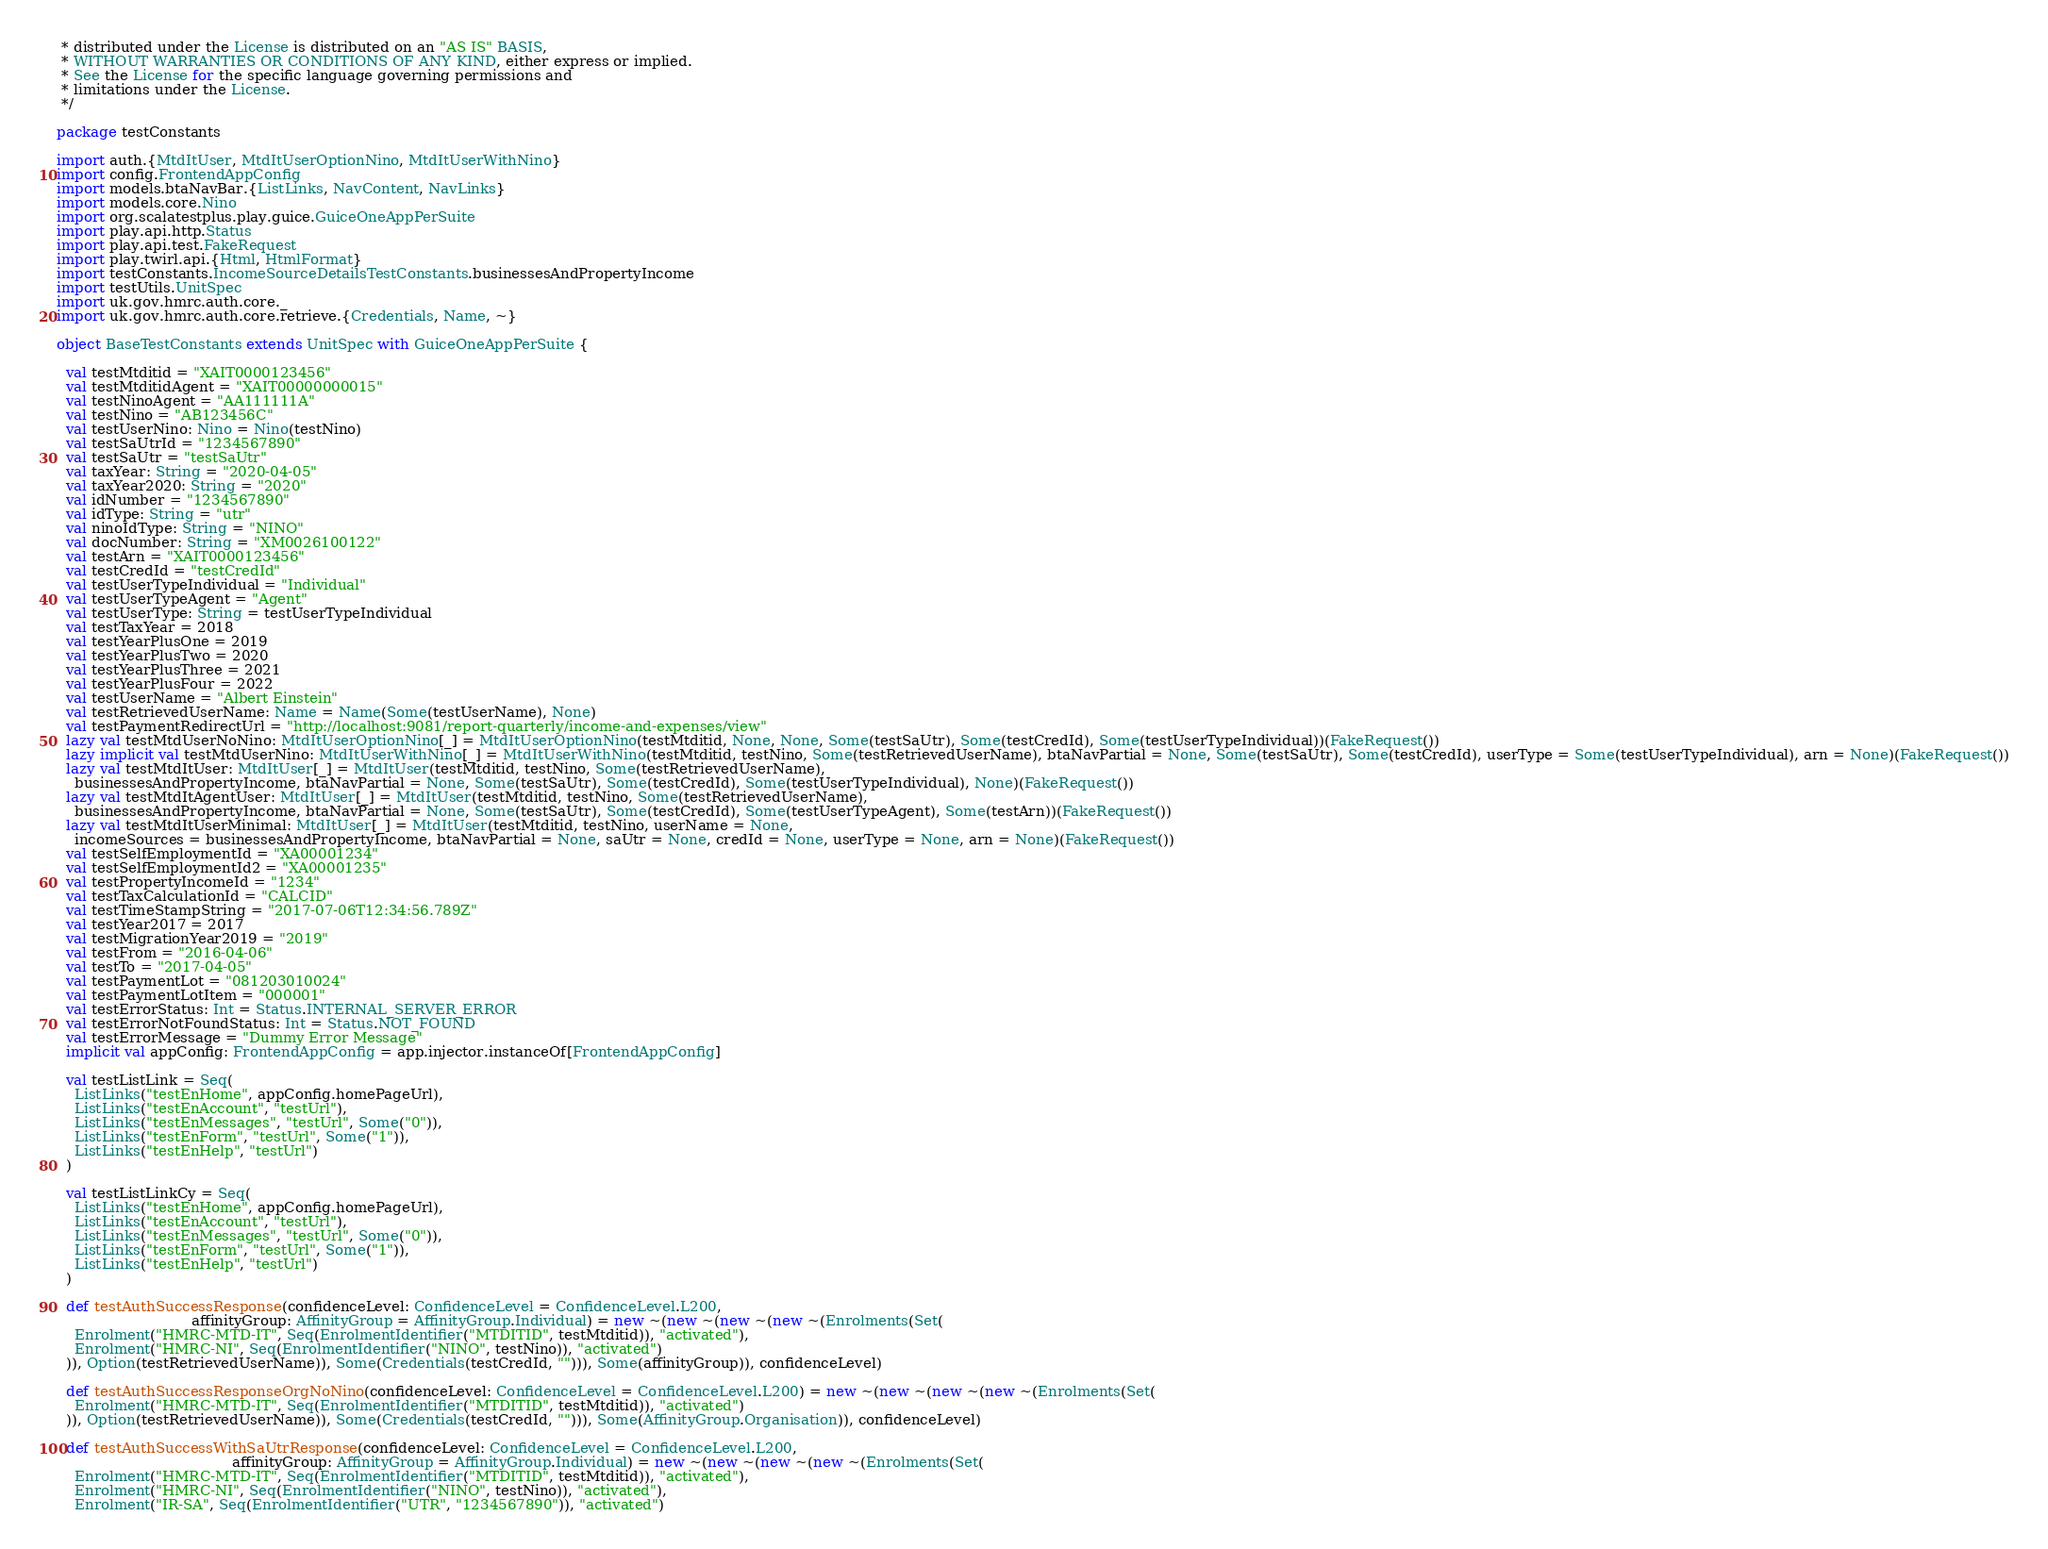Convert code to text. <code><loc_0><loc_0><loc_500><loc_500><_Scala_> * distributed under the License is distributed on an "AS IS" BASIS,
 * WITHOUT WARRANTIES OR CONDITIONS OF ANY KIND, either express or implied.
 * See the License for the specific language governing permissions and
 * limitations under the License.
 */

package testConstants

import auth.{MtdItUser, MtdItUserOptionNino, MtdItUserWithNino}
import config.FrontendAppConfig
import models.btaNavBar.{ListLinks, NavContent, NavLinks}
import models.core.Nino
import org.scalatestplus.play.guice.GuiceOneAppPerSuite
import play.api.http.Status
import play.api.test.FakeRequest
import play.twirl.api.{Html, HtmlFormat}
import testConstants.IncomeSourceDetailsTestConstants.businessesAndPropertyIncome
import testUtils.UnitSpec
import uk.gov.hmrc.auth.core._
import uk.gov.hmrc.auth.core.retrieve.{Credentials, Name, ~}

object BaseTestConstants extends UnitSpec with GuiceOneAppPerSuite {

  val testMtditid = "XAIT0000123456"
  val testMtditidAgent = "XAIT00000000015"
  val testNinoAgent = "AA111111A"
  val testNino = "AB123456C"
  val testUserNino: Nino = Nino(testNino)
  val testSaUtrId = "1234567890"
  val testSaUtr = "testSaUtr"
  val taxYear: String = "2020-04-05"
  val taxYear2020: String = "2020"
  val idNumber = "1234567890"
  val idType: String = "utr"
  val ninoIdType: String = "NINO"
  val docNumber: String = "XM0026100122"
  val testArn = "XAIT0000123456"
  val testCredId = "testCredId"
  val testUserTypeIndividual = "Individual"
  val testUserTypeAgent = "Agent"
  val testUserType: String = testUserTypeIndividual
  val testTaxYear = 2018
  val testYearPlusOne = 2019
  val testYearPlusTwo = 2020
  val testYearPlusThree = 2021
  val testYearPlusFour = 2022
  val testUserName = "Albert Einstein"
  val testRetrievedUserName: Name = Name(Some(testUserName), None)
  val testPaymentRedirectUrl = "http://localhost:9081/report-quarterly/income-and-expenses/view"
  lazy val testMtdUserNoNino: MtdItUserOptionNino[_] = MtdItUserOptionNino(testMtditid, None, None, Some(testSaUtr), Some(testCredId), Some(testUserTypeIndividual))(FakeRequest())
  lazy implicit val testMtdUserNino: MtdItUserWithNino[_] = MtdItUserWithNino(testMtditid, testNino, Some(testRetrievedUserName), btaNavPartial = None, Some(testSaUtr), Some(testCredId), userType = Some(testUserTypeIndividual), arn = None)(FakeRequest())
  lazy val testMtdItUser: MtdItUser[_] = MtdItUser(testMtditid, testNino, Some(testRetrievedUserName),
    businessesAndPropertyIncome, btaNavPartial = None, Some(testSaUtr), Some(testCredId), Some(testUserTypeIndividual), None)(FakeRequest())
  lazy val testMtdItAgentUser: MtdItUser[_] = MtdItUser(testMtditid, testNino, Some(testRetrievedUserName),
    businessesAndPropertyIncome, btaNavPartial = None, Some(testSaUtr), Some(testCredId), Some(testUserTypeAgent), Some(testArn))(FakeRequest())
  lazy val testMtdItUserMinimal: MtdItUser[_] = MtdItUser(testMtditid, testNino, userName = None,
    incomeSources = businessesAndPropertyIncome, btaNavPartial = None, saUtr = None, credId = None, userType = None, arn = None)(FakeRequest())
  val testSelfEmploymentId = "XA00001234"
  val testSelfEmploymentId2 = "XA00001235"
  val testPropertyIncomeId = "1234"
  val testTaxCalculationId = "CALCID"
  val testTimeStampString = "2017-07-06T12:34:56.789Z"
  val testYear2017 = 2017
  val testMigrationYear2019 = "2019"
  val testFrom = "2016-04-06"
  val testTo = "2017-04-05"
  val testPaymentLot = "081203010024"
  val testPaymentLotItem = "000001"
  val testErrorStatus: Int = Status.INTERNAL_SERVER_ERROR
  val testErrorNotFoundStatus: Int = Status.NOT_FOUND
  val testErrorMessage = "Dummy Error Message"
  implicit val appConfig: FrontendAppConfig = app.injector.instanceOf[FrontendAppConfig]

  val testListLink = Seq(
    ListLinks("testEnHome", appConfig.homePageUrl),
    ListLinks("testEnAccount", "testUrl"),
    ListLinks("testEnMessages", "testUrl", Some("0")),
    ListLinks("testEnForm", "testUrl", Some("1")),
    ListLinks("testEnHelp", "testUrl")
  )

  val testListLinkCy = Seq(
    ListLinks("testEnHome", appConfig.homePageUrl),
    ListLinks("testEnAccount", "testUrl"),
    ListLinks("testEnMessages", "testUrl", Some("0")),
    ListLinks("testEnForm", "testUrl", Some("1")),
    ListLinks("testEnHelp", "testUrl")
  )

  def testAuthSuccessResponse(confidenceLevel: ConfidenceLevel = ConfidenceLevel.L200,
                              affinityGroup: AffinityGroup = AffinityGroup.Individual) = new ~(new ~(new ~(new ~(Enrolments(Set(
    Enrolment("HMRC-MTD-IT", Seq(EnrolmentIdentifier("MTDITID", testMtditid)), "activated"),
    Enrolment("HMRC-NI", Seq(EnrolmentIdentifier("NINO", testNino)), "activated")
  )), Option(testRetrievedUserName)), Some(Credentials(testCredId, ""))), Some(affinityGroup)), confidenceLevel)

  def testAuthSuccessResponseOrgNoNino(confidenceLevel: ConfidenceLevel = ConfidenceLevel.L200) = new ~(new ~(new ~(new ~(Enrolments(Set(
    Enrolment("HMRC-MTD-IT", Seq(EnrolmentIdentifier("MTDITID", testMtditid)), "activated")
  )), Option(testRetrievedUserName)), Some(Credentials(testCredId, ""))), Some(AffinityGroup.Organisation)), confidenceLevel)

  def testAuthSuccessWithSaUtrResponse(confidenceLevel: ConfidenceLevel = ConfidenceLevel.L200,
                                       affinityGroup: AffinityGroup = AffinityGroup.Individual) = new ~(new ~(new ~(new ~(Enrolments(Set(
    Enrolment("HMRC-MTD-IT", Seq(EnrolmentIdentifier("MTDITID", testMtditid)), "activated"),
    Enrolment("HMRC-NI", Seq(EnrolmentIdentifier("NINO", testNino)), "activated"),
    Enrolment("IR-SA", Seq(EnrolmentIdentifier("UTR", "1234567890")), "activated")</code> 